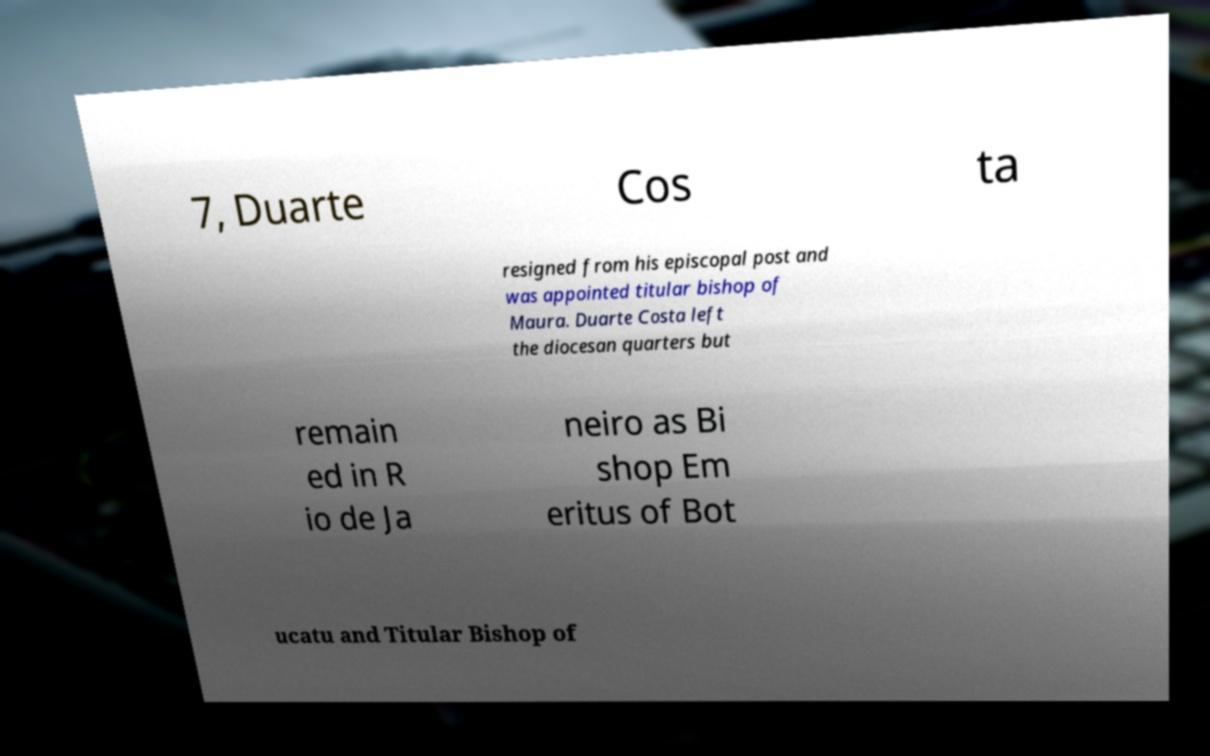Please read and relay the text visible in this image. What does it say? 7, Duarte Cos ta resigned from his episcopal post and was appointed titular bishop of Maura. Duarte Costa left the diocesan quarters but remain ed in R io de Ja neiro as Bi shop Em eritus of Bot ucatu and Titular Bishop of 